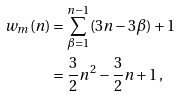Convert formula to latex. <formula><loc_0><loc_0><loc_500><loc_500>w _ { m } ( n ) & = \sum _ { \beta = 1 } ^ { n - 1 } ( 3 n - 3 \beta ) + 1 \\ & = \frac { 3 } { 2 } n ^ { 2 } - \frac { 3 } { 2 } n + 1 \, ,</formula> 